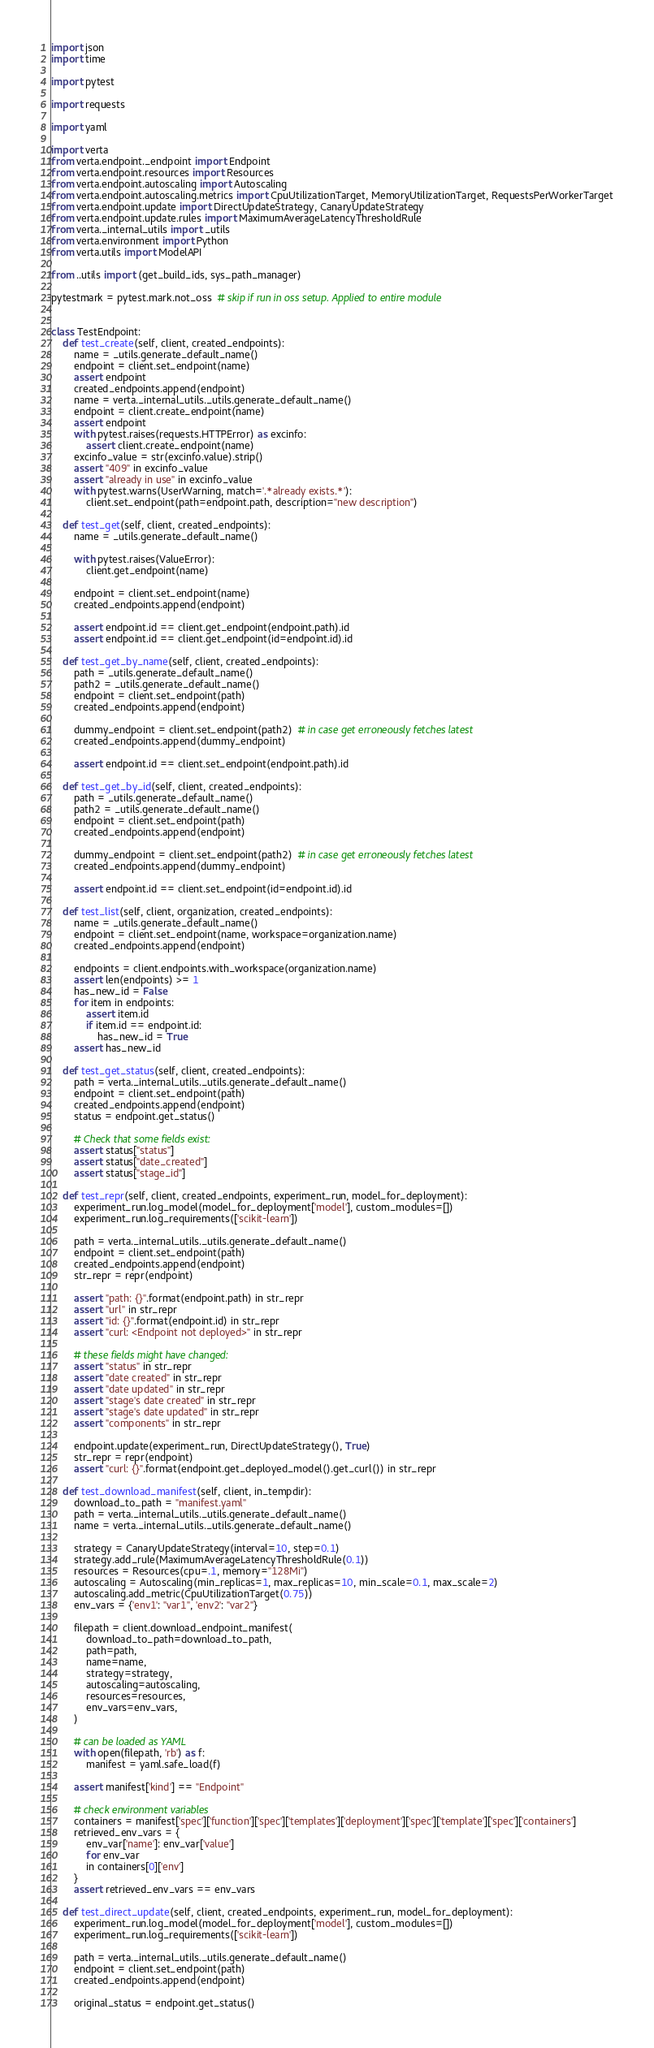Convert code to text. <code><loc_0><loc_0><loc_500><loc_500><_Python_>import json
import time

import pytest

import requests

import yaml

import verta
from verta.endpoint._endpoint import Endpoint
from verta.endpoint.resources import Resources
from verta.endpoint.autoscaling import Autoscaling
from verta.endpoint.autoscaling.metrics import CpuUtilizationTarget, MemoryUtilizationTarget, RequestsPerWorkerTarget
from verta.endpoint.update import DirectUpdateStrategy, CanaryUpdateStrategy
from verta.endpoint.update.rules import MaximumAverageLatencyThresholdRule
from verta._internal_utils import _utils
from verta.environment import Python
from verta.utils import ModelAPI

from ..utils import (get_build_ids, sys_path_manager)

pytestmark = pytest.mark.not_oss  # skip if run in oss setup. Applied to entire module


class TestEndpoint:
    def test_create(self, client, created_endpoints):
        name = _utils.generate_default_name()
        endpoint = client.set_endpoint(name)
        assert endpoint
        created_endpoints.append(endpoint)
        name = verta._internal_utils._utils.generate_default_name()
        endpoint = client.create_endpoint(name)
        assert endpoint
        with pytest.raises(requests.HTTPError) as excinfo:
            assert client.create_endpoint(name)
        excinfo_value = str(excinfo.value).strip()
        assert "409" in excinfo_value
        assert "already in use" in excinfo_value
        with pytest.warns(UserWarning, match='.*already exists.*'):
            client.set_endpoint(path=endpoint.path, description="new description")

    def test_get(self, client, created_endpoints):
        name = _utils.generate_default_name()

        with pytest.raises(ValueError):
            client.get_endpoint(name)

        endpoint = client.set_endpoint(name)
        created_endpoints.append(endpoint)

        assert endpoint.id == client.get_endpoint(endpoint.path).id
        assert endpoint.id == client.get_endpoint(id=endpoint.id).id

    def test_get_by_name(self, client, created_endpoints):
        path = _utils.generate_default_name()
        path2 = _utils.generate_default_name()
        endpoint = client.set_endpoint(path)
        created_endpoints.append(endpoint)

        dummy_endpoint = client.set_endpoint(path2)  # in case get erroneously fetches latest
        created_endpoints.append(dummy_endpoint)

        assert endpoint.id == client.set_endpoint(endpoint.path).id

    def test_get_by_id(self, client, created_endpoints):
        path = _utils.generate_default_name()
        path2 = _utils.generate_default_name()
        endpoint = client.set_endpoint(path)
        created_endpoints.append(endpoint)

        dummy_endpoint = client.set_endpoint(path2)  # in case get erroneously fetches latest
        created_endpoints.append(dummy_endpoint)

        assert endpoint.id == client.set_endpoint(id=endpoint.id).id

    def test_list(self, client, organization, created_endpoints):
        name = _utils.generate_default_name()
        endpoint = client.set_endpoint(name, workspace=organization.name)
        created_endpoints.append(endpoint)

        endpoints = client.endpoints.with_workspace(organization.name)
        assert len(endpoints) >= 1
        has_new_id = False
        for item in endpoints:
            assert item.id
            if item.id == endpoint.id:
                has_new_id = True
        assert has_new_id

    def test_get_status(self, client, created_endpoints):
        path = verta._internal_utils._utils.generate_default_name()
        endpoint = client.set_endpoint(path)
        created_endpoints.append(endpoint)
        status = endpoint.get_status()

        # Check that some fields exist:
        assert status["status"]
        assert status["date_created"]
        assert status["stage_id"]

    def test_repr(self, client, created_endpoints, experiment_run, model_for_deployment):
        experiment_run.log_model(model_for_deployment['model'], custom_modules=[])
        experiment_run.log_requirements(['scikit-learn'])

        path = verta._internal_utils._utils.generate_default_name()
        endpoint = client.set_endpoint(path)
        created_endpoints.append(endpoint)
        str_repr = repr(endpoint)

        assert "path: {}".format(endpoint.path) in str_repr
        assert "url" in str_repr
        assert "id: {}".format(endpoint.id) in str_repr
        assert "curl: <Endpoint not deployed>" in str_repr

        # these fields might have changed:
        assert "status" in str_repr
        assert "date created" in str_repr
        assert "date updated" in str_repr
        assert "stage's date created" in str_repr
        assert "stage's date updated" in str_repr
        assert "components" in str_repr

        endpoint.update(experiment_run, DirectUpdateStrategy(), True)
        str_repr = repr(endpoint)
        assert "curl: {}".format(endpoint.get_deployed_model().get_curl()) in str_repr

    def test_download_manifest(self, client, in_tempdir):
        download_to_path = "manifest.yaml"
        path = verta._internal_utils._utils.generate_default_name()
        name = verta._internal_utils._utils.generate_default_name()

        strategy = CanaryUpdateStrategy(interval=10, step=0.1)
        strategy.add_rule(MaximumAverageLatencyThresholdRule(0.1))
        resources = Resources(cpu=.1, memory="128Mi")
        autoscaling = Autoscaling(min_replicas=1, max_replicas=10, min_scale=0.1, max_scale=2)
        autoscaling.add_metric(CpuUtilizationTarget(0.75))
        env_vars = {'env1': "var1", 'env2': "var2"}

        filepath = client.download_endpoint_manifest(
            download_to_path=download_to_path,
            path=path,
            name=name,
            strategy=strategy,
            autoscaling=autoscaling,
            resources=resources,
            env_vars=env_vars,
        )

        # can be loaded as YAML
        with open(filepath, 'rb') as f:
            manifest = yaml.safe_load(f)

        assert manifest['kind'] == "Endpoint"

        # check environment variables
        containers = manifest['spec']['function']['spec']['templates']['deployment']['spec']['template']['spec']['containers']
        retrieved_env_vars = {
            env_var['name']: env_var['value']
            for env_var
            in containers[0]['env']
        }
        assert retrieved_env_vars == env_vars

    def test_direct_update(self, client, created_endpoints, experiment_run, model_for_deployment):
        experiment_run.log_model(model_for_deployment['model'], custom_modules=[])
        experiment_run.log_requirements(['scikit-learn'])

        path = verta._internal_utils._utils.generate_default_name()
        endpoint = client.set_endpoint(path)
        created_endpoints.append(endpoint)

        original_status = endpoint.get_status()</code> 